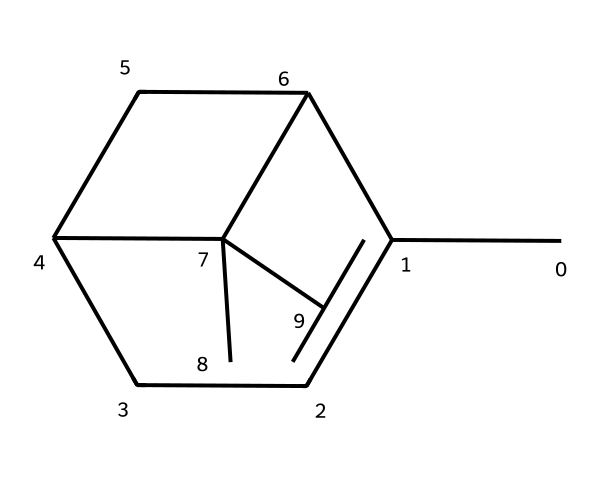How many carbon atoms are in pinene? Counting the carbon (C) atoms in the SMILES representation, there are a total of 10 carbon atoms present.
Answer: 10 What is the molecular formula of pinene? By analyzing the number of carbon and hydrogen atoms in the structure, the molecular formula can be derived as C10H16.
Answer: C10H16 How many double bonds are present in pinene? In the structure, there is 1 double bond visible between the carbons, indicating there is one double bond in pinene.
Answer: 1 What type of chemical is pinene classified as? Pinene is classified as a terpene due to its structural characteristics, notably having a specific arrangement of carbon and hydrogen that is typical for terpenes.
Answer: terpene What is the degree of unsaturation in pinene? The degree of unsaturation can be calculated based on the formula: (2C + 2 - H)/2. Using 10 carbons and 16 hydrogens, this results in a degree of unsaturation of 1.
Answer: 1 Which functional group is likely present in pinene? The SMILES representation suggests the presence of cycloalkene characteristics due to its ring structure and the double bond, indicating it may possess functionalities similar to cycloalkenes.
Answer: cycloalkene 